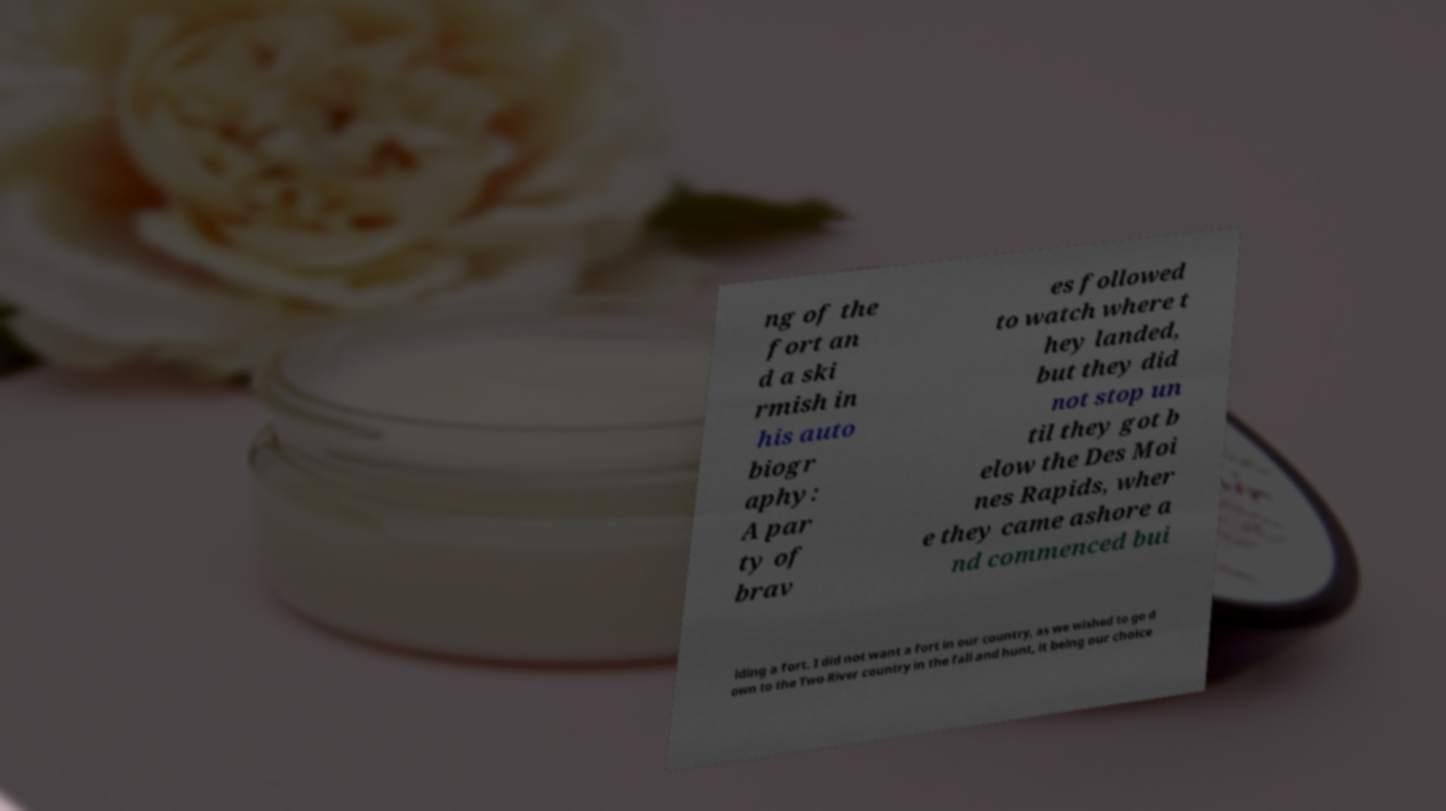There's text embedded in this image that I need extracted. Can you transcribe it verbatim? ng of the fort an d a ski rmish in his auto biogr aphy: A par ty of brav es followed to watch where t hey landed, but they did not stop un til they got b elow the Des Moi nes Rapids, wher e they came ashore a nd commenced bui lding a fort. I did not want a fort in our country, as we wished to go d own to the Two River country in the fall and hunt, it being our choice 